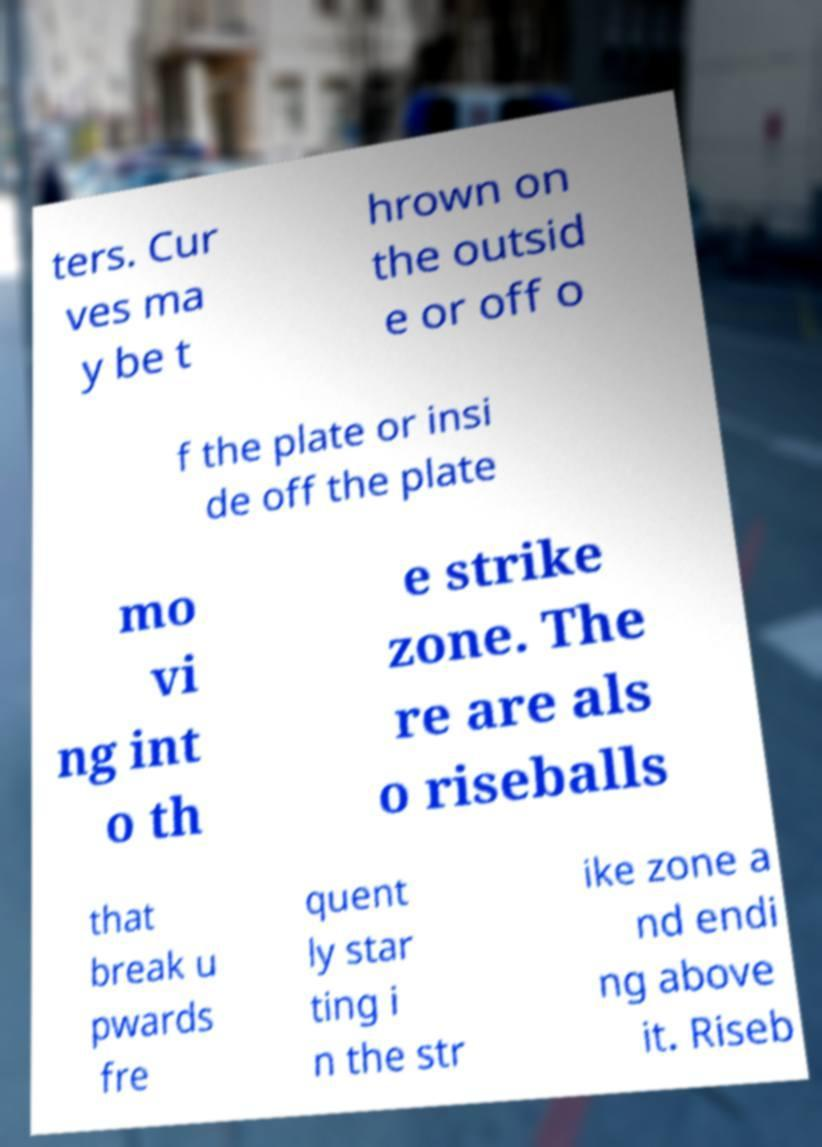Please read and relay the text visible in this image. What does it say? ters. Cur ves ma y be t hrown on the outsid e or off o f the plate or insi de off the plate mo vi ng int o th e strike zone. The re are als o riseballs that break u pwards fre quent ly star ting i n the str ike zone a nd endi ng above it. Riseb 